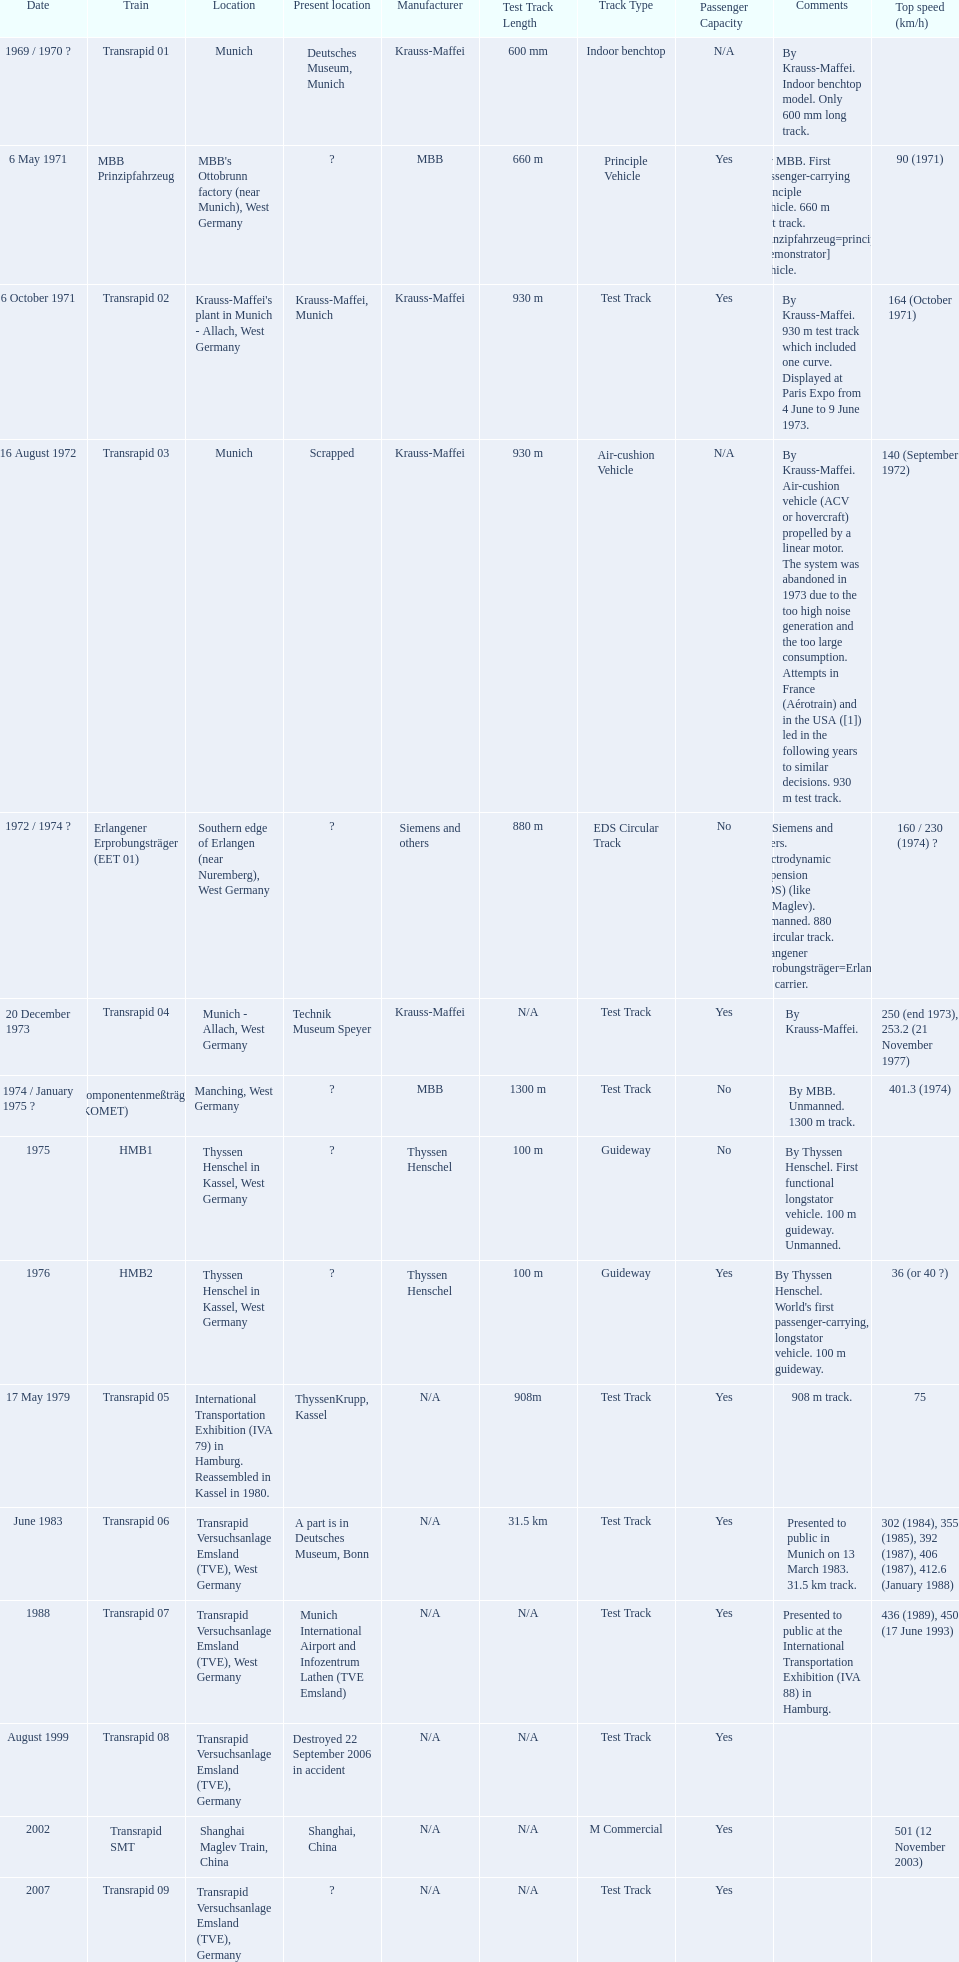What are all trains? Transrapid 01, MBB Prinzipfahrzeug, Transrapid 02, Transrapid 03, Erlangener Erprobungsträger (EET 01), Transrapid 04, Komponentenmeßträger (KOMET), HMB1, HMB2, Transrapid 05, Transrapid 06, Transrapid 07, Transrapid 08, Transrapid SMT, Transrapid 09. Which of all location of trains are known? Deutsches Museum, Munich, Krauss-Maffei, Munich, Scrapped, Technik Museum Speyer, ThyssenKrupp, Kassel, A part is in Deutsches Museum, Bonn, Munich International Airport and Infozentrum Lathen (TVE Emsland), Destroyed 22 September 2006 in accident, Shanghai, China. Which of those trains were scrapped? Transrapid 03. 